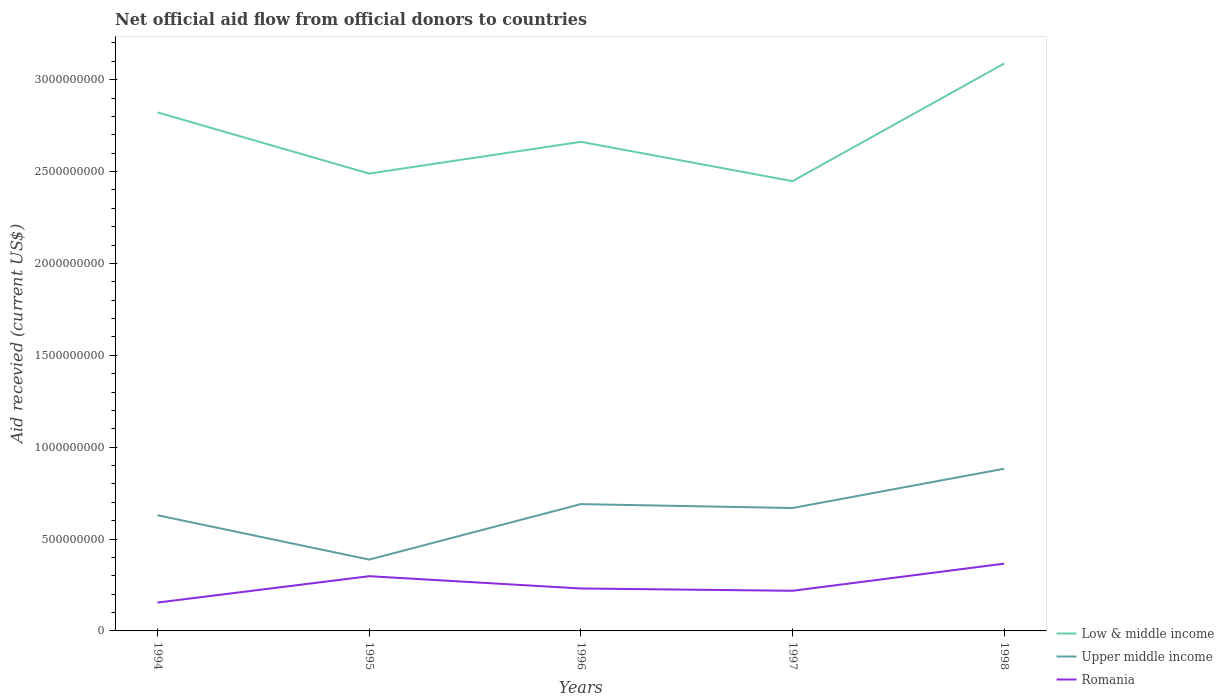Is the number of lines equal to the number of legend labels?
Give a very brief answer. Yes. Across all years, what is the maximum total aid received in Upper middle income?
Ensure brevity in your answer.  3.88e+08. In which year was the total aid received in Upper middle income maximum?
Offer a terse response. 1995. What is the total total aid received in Low & middle income in the graph?
Give a very brief answer. 2.14e+08. What is the difference between the highest and the second highest total aid received in Upper middle income?
Your response must be concise. 4.94e+08. What is the difference between the highest and the lowest total aid received in Upper middle income?
Provide a succinct answer. 3. How many years are there in the graph?
Offer a very short reply. 5. Are the values on the major ticks of Y-axis written in scientific E-notation?
Offer a very short reply. No. Does the graph contain grids?
Offer a very short reply. No. Where does the legend appear in the graph?
Ensure brevity in your answer.  Bottom right. How many legend labels are there?
Your response must be concise. 3. What is the title of the graph?
Provide a succinct answer. Net official aid flow from official donors to countries. What is the label or title of the X-axis?
Your answer should be compact. Years. What is the label or title of the Y-axis?
Ensure brevity in your answer.  Aid recevied (current US$). What is the Aid recevied (current US$) in Low & middle income in 1994?
Make the answer very short. 2.82e+09. What is the Aid recevied (current US$) in Upper middle income in 1994?
Give a very brief answer. 6.30e+08. What is the Aid recevied (current US$) of Romania in 1994?
Provide a short and direct response. 1.54e+08. What is the Aid recevied (current US$) of Low & middle income in 1995?
Provide a short and direct response. 2.49e+09. What is the Aid recevied (current US$) of Upper middle income in 1995?
Offer a very short reply. 3.88e+08. What is the Aid recevied (current US$) in Romania in 1995?
Provide a succinct answer. 2.98e+08. What is the Aid recevied (current US$) in Low & middle income in 1996?
Offer a terse response. 2.66e+09. What is the Aid recevied (current US$) of Upper middle income in 1996?
Offer a terse response. 6.90e+08. What is the Aid recevied (current US$) of Romania in 1996?
Your answer should be very brief. 2.31e+08. What is the Aid recevied (current US$) in Low & middle income in 1997?
Provide a succinct answer. 2.45e+09. What is the Aid recevied (current US$) of Upper middle income in 1997?
Your answer should be very brief. 6.69e+08. What is the Aid recevied (current US$) of Romania in 1997?
Provide a succinct answer. 2.18e+08. What is the Aid recevied (current US$) of Low & middle income in 1998?
Your response must be concise. 3.09e+09. What is the Aid recevied (current US$) of Upper middle income in 1998?
Offer a terse response. 8.83e+08. What is the Aid recevied (current US$) in Romania in 1998?
Offer a very short reply. 3.66e+08. Across all years, what is the maximum Aid recevied (current US$) in Low & middle income?
Offer a very short reply. 3.09e+09. Across all years, what is the maximum Aid recevied (current US$) in Upper middle income?
Offer a terse response. 8.83e+08. Across all years, what is the maximum Aid recevied (current US$) of Romania?
Give a very brief answer. 3.66e+08. Across all years, what is the minimum Aid recevied (current US$) in Low & middle income?
Offer a terse response. 2.45e+09. Across all years, what is the minimum Aid recevied (current US$) of Upper middle income?
Offer a terse response. 3.88e+08. Across all years, what is the minimum Aid recevied (current US$) in Romania?
Your answer should be very brief. 1.54e+08. What is the total Aid recevied (current US$) of Low & middle income in the graph?
Ensure brevity in your answer.  1.35e+1. What is the total Aid recevied (current US$) in Upper middle income in the graph?
Your answer should be very brief. 3.26e+09. What is the total Aid recevied (current US$) in Romania in the graph?
Your answer should be very brief. 1.27e+09. What is the difference between the Aid recevied (current US$) in Low & middle income in 1994 and that in 1995?
Make the answer very short. 3.33e+08. What is the difference between the Aid recevied (current US$) of Upper middle income in 1994 and that in 1995?
Provide a succinct answer. 2.41e+08. What is the difference between the Aid recevied (current US$) in Romania in 1994 and that in 1995?
Keep it short and to the point. -1.43e+08. What is the difference between the Aid recevied (current US$) in Low & middle income in 1994 and that in 1996?
Make the answer very short. 1.60e+08. What is the difference between the Aid recevied (current US$) of Upper middle income in 1994 and that in 1996?
Ensure brevity in your answer.  -6.04e+07. What is the difference between the Aid recevied (current US$) in Romania in 1994 and that in 1996?
Give a very brief answer. -7.65e+07. What is the difference between the Aid recevied (current US$) in Low & middle income in 1994 and that in 1997?
Offer a terse response. 3.74e+08. What is the difference between the Aid recevied (current US$) of Upper middle income in 1994 and that in 1997?
Offer a very short reply. -3.93e+07. What is the difference between the Aid recevied (current US$) of Romania in 1994 and that in 1997?
Keep it short and to the point. -6.40e+07. What is the difference between the Aid recevied (current US$) of Low & middle income in 1994 and that in 1998?
Your response must be concise. -2.66e+08. What is the difference between the Aid recevied (current US$) in Upper middle income in 1994 and that in 1998?
Your response must be concise. -2.53e+08. What is the difference between the Aid recevied (current US$) in Romania in 1994 and that in 1998?
Your answer should be very brief. -2.12e+08. What is the difference between the Aid recevied (current US$) of Low & middle income in 1995 and that in 1996?
Provide a succinct answer. -1.73e+08. What is the difference between the Aid recevied (current US$) in Upper middle income in 1995 and that in 1996?
Your answer should be very brief. -3.02e+08. What is the difference between the Aid recevied (current US$) in Romania in 1995 and that in 1996?
Make the answer very short. 6.69e+07. What is the difference between the Aid recevied (current US$) of Low & middle income in 1995 and that in 1997?
Your answer should be compact. 4.13e+07. What is the difference between the Aid recevied (current US$) in Upper middle income in 1995 and that in 1997?
Make the answer very short. -2.81e+08. What is the difference between the Aid recevied (current US$) of Romania in 1995 and that in 1997?
Your response must be concise. 7.94e+07. What is the difference between the Aid recevied (current US$) in Low & middle income in 1995 and that in 1998?
Keep it short and to the point. -5.99e+08. What is the difference between the Aid recevied (current US$) in Upper middle income in 1995 and that in 1998?
Make the answer very short. -4.94e+08. What is the difference between the Aid recevied (current US$) of Romania in 1995 and that in 1998?
Offer a terse response. -6.83e+07. What is the difference between the Aid recevied (current US$) of Low & middle income in 1996 and that in 1997?
Ensure brevity in your answer.  2.14e+08. What is the difference between the Aid recevied (current US$) of Upper middle income in 1996 and that in 1997?
Offer a very short reply. 2.11e+07. What is the difference between the Aid recevied (current US$) in Romania in 1996 and that in 1997?
Your answer should be very brief. 1.25e+07. What is the difference between the Aid recevied (current US$) in Low & middle income in 1996 and that in 1998?
Offer a terse response. -4.26e+08. What is the difference between the Aid recevied (current US$) of Upper middle income in 1996 and that in 1998?
Your answer should be compact. -1.93e+08. What is the difference between the Aid recevied (current US$) of Romania in 1996 and that in 1998?
Keep it short and to the point. -1.35e+08. What is the difference between the Aid recevied (current US$) in Low & middle income in 1997 and that in 1998?
Ensure brevity in your answer.  -6.40e+08. What is the difference between the Aid recevied (current US$) of Upper middle income in 1997 and that in 1998?
Offer a terse response. -2.14e+08. What is the difference between the Aid recevied (current US$) of Romania in 1997 and that in 1998?
Your answer should be very brief. -1.48e+08. What is the difference between the Aid recevied (current US$) in Low & middle income in 1994 and the Aid recevied (current US$) in Upper middle income in 1995?
Offer a terse response. 2.43e+09. What is the difference between the Aid recevied (current US$) in Low & middle income in 1994 and the Aid recevied (current US$) in Romania in 1995?
Give a very brief answer. 2.52e+09. What is the difference between the Aid recevied (current US$) in Upper middle income in 1994 and the Aid recevied (current US$) in Romania in 1995?
Give a very brief answer. 3.32e+08. What is the difference between the Aid recevied (current US$) in Low & middle income in 1994 and the Aid recevied (current US$) in Upper middle income in 1996?
Offer a very short reply. 2.13e+09. What is the difference between the Aid recevied (current US$) in Low & middle income in 1994 and the Aid recevied (current US$) in Romania in 1996?
Offer a terse response. 2.59e+09. What is the difference between the Aid recevied (current US$) in Upper middle income in 1994 and the Aid recevied (current US$) in Romania in 1996?
Make the answer very short. 3.99e+08. What is the difference between the Aid recevied (current US$) in Low & middle income in 1994 and the Aid recevied (current US$) in Upper middle income in 1997?
Give a very brief answer. 2.15e+09. What is the difference between the Aid recevied (current US$) of Low & middle income in 1994 and the Aid recevied (current US$) of Romania in 1997?
Your answer should be very brief. 2.60e+09. What is the difference between the Aid recevied (current US$) in Upper middle income in 1994 and the Aid recevied (current US$) in Romania in 1997?
Provide a short and direct response. 4.11e+08. What is the difference between the Aid recevied (current US$) in Low & middle income in 1994 and the Aid recevied (current US$) in Upper middle income in 1998?
Ensure brevity in your answer.  1.94e+09. What is the difference between the Aid recevied (current US$) in Low & middle income in 1994 and the Aid recevied (current US$) in Romania in 1998?
Your answer should be very brief. 2.46e+09. What is the difference between the Aid recevied (current US$) in Upper middle income in 1994 and the Aid recevied (current US$) in Romania in 1998?
Provide a succinct answer. 2.64e+08. What is the difference between the Aid recevied (current US$) in Low & middle income in 1995 and the Aid recevied (current US$) in Upper middle income in 1996?
Ensure brevity in your answer.  1.80e+09. What is the difference between the Aid recevied (current US$) of Low & middle income in 1995 and the Aid recevied (current US$) of Romania in 1996?
Offer a very short reply. 2.26e+09. What is the difference between the Aid recevied (current US$) of Upper middle income in 1995 and the Aid recevied (current US$) of Romania in 1996?
Make the answer very short. 1.57e+08. What is the difference between the Aid recevied (current US$) in Low & middle income in 1995 and the Aid recevied (current US$) in Upper middle income in 1997?
Offer a terse response. 1.82e+09. What is the difference between the Aid recevied (current US$) in Low & middle income in 1995 and the Aid recevied (current US$) in Romania in 1997?
Your response must be concise. 2.27e+09. What is the difference between the Aid recevied (current US$) of Upper middle income in 1995 and the Aid recevied (current US$) of Romania in 1997?
Keep it short and to the point. 1.70e+08. What is the difference between the Aid recevied (current US$) in Low & middle income in 1995 and the Aid recevied (current US$) in Upper middle income in 1998?
Make the answer very short. 1.61e+09. What is the difference between the Aid recevied (current US$) of Low & middle income in 1995 and the Aid recevied (current US$) of Romania in 1998?
Make the answer very short. 2.12e+09. What is the difference between the Aid recevied (current US$) of Upper middle income in 1995 and the Aid recevied (current US$) of Romania in 1998?
Provide a short and direct response. 2.21e+07. What is the difference between the Aid recevied (current US$) in Low & middle income in 1996 and the Aid recevied (current US$) in Upper middle income in 1997?
Offer a very short reply. 1.99e+09. What is the difference between the Aid recevied (current US$) in Low & middle income in 1996 and the Aid recevied (current US$) in Romania in 1997?
Keep it short and to the point. 2.44e+09. What is the difference between the Aid recevied (current US$) in Upper middle income in 1996 and the Aid recevied (current US$) in Romania in 1997?
Give a very brief answer. 4.72e+08. What is the difference between the Aid recevied (current US$) in Low & middle income in 1996 and the Aid recevied (current US$) in Upper middle income in 1998?
Offer a terse response. 1.78e+09. What is the difference between the Aid recevied (current US$) of Low & middle income in 1996 and the Aid recevied (current US$) of Romania in 1998?
Provide a succinct answer. 2.30e+09. What is the difference between the Aid recevied (current US$) in Upper middle income in 1996 and the Aid recevied (current US$) in Romania in 1998?
Make the answer very short. 3.24e+08. What is the difference between the Aid recevied (current US$) of Low & middle income in 1997 and the Aid recevied (current US$) of Upper middle income in 1998?
Make the answer very short. 1.57e+09. What is the difference between the Aid recevied (current US$) in Low & middle income in 1997 and the Aid recevied (current US$) in Romania in 1998?
Provide a short and direct response. 2.08e+09. What is the difference between the Aid recevied (current US$) of Upper middle income in 1997 and the Aid recevied (current US$) of Romania in 1998?
Your answer should be very brief. 3.03e+08. What is the average Aid recevied (current US$) of Low & middle income per year?
Provide a short and direct response. 2.70e+09. What is the average Aid recevied (current US$) in Upper middle income per year?
Give a very brief answer. 6.52e+08. What is the average Aid recevied (current US$) of Romania per year?
Give a very brief answer. 2.54e+08. In the year 1994, what is the difference between the Aid recevied (current US$) of Low & middle income and Aid recevied (current US$) of Upper middle income?
Your answer should be very brief. 2.19e+09. In the year 1994, what is the difference between the Aid recevied (current US$) of Low & middle income and Aid recevied (current US$) of Romania?
Your response must be concise. 2.67e+09. In the year 1994, what is the difference between the Aid recevied (current US$) in Upper middle income and Aid recevied (current US$) in Romania?
Offer a very short reply. 4.75e+08. In the year 1995, what is the difference between the Aid recevied (current US$) in Low & middle income and Aid recevied (current US$) in Upper middle income?
Give a very brief answer. 2.10e+09. In the year 1995, what is the difference between the Aid recevied (current US$) in Low & middle income and Aid recevied (current US$) in Romania?
Ensure brevity in your answer.  2.19e+09. In the year 1995, what is the difference between the Aid recevied (current US$) of Upper middle income and Aid recevied (current US$) of Romania?
Offer a terse response. 9.04e+07. In the year 1996, what is the difference between the Aid recevied (current US$) in Low & middle income and Aid recevied (current US$) in Upper middle income?
Give a very brief answer. 1.97e+09. In the year 1996, what is the difference between the Aid recevied (current US$) of Low & middle income and Aid recevied (current US$) of Romania?
Your response must be concise. 2.43e+09. In the year 1996, what is the difference between the Aid recevied (current US$) in Upper middle income and Aid recevied (current US$) in Romania?
Provide a succinct answer. 4.59e+08. In the year 1997, what is the difference between the Aid recevied (current US$) of Low & middle income and Aid recevied (current US$) of Upper middle income?
Provide a short and direct response. 1.78e+09. In the year 1997, what is the difference between the Aid recevied (current US$) of Low & middle income and Aid recevied (current US$) of Romania?
Ensure brevity in your answer.  2.23e+09. In the year 1997, what is the difference between the Aid recevied (current US$) in Upper middle income and Aid recevied (current US$) in Romania?
Provide a short and direct response. 4.51e+08. In the year 1998, what is the difference between the Aid recevied (current US$) of Low & middle income and Aid recevied (current US$) of Upper middle income?
Give a very brief answer. 2.21e+09. In the year 1998, what is the difference between the Aid recevied (current US$) of Low & middle income and Aid recevied (current US$) of Romania?
Provide a short and direct response. 2.72e+09. In the year 1998, what is the difference between the Aid recevied (current US$) in Upper middle income and Aid recevied (current US$) in Romania?
Your answer should be very brief. 5.17e+08. What is the ratio of the Aid recevied (current US$) in Low & middle income in 1994 to that in 1995?
Offer a very short reply. 1.13. What is the ratio of the Aid recevied (current US$) of Upper middle income in 1994 to that in 1995?
Ensure brevity in your answer.  1.62. What is the ratio of the Aid recevied (current US$) of Romania in 1994 to that in 1995?
Your response must be concise. 0.52. What is the ratio of the Aid recevied (current US$) of Low & middle income in 1994 to that in 1996?
Give a very brief answer. 1.06. What is the ratio of the Aid recevied (current US$) in Upper middle income in 1994 to that in 1996?
Ensure brevity in your answer.  0.91. What is the ratio of the Aid recevied (current US$) of Romania in 1994 to that in 1996?
Give a very brief answer. 0.67. What is the ratio of the Aid recevied (current US$) in Low & middle income in 1994 to that in 1997?
Offer a terse response. 1.15. What is the ratio of the Aid recevied (current US$) of Upper middle income in 1994 to that in 1997?
Make the answer very short. 0.94. What is the ratio of the Aid recevied (current US$) in Romania in 1994 to that in 1997?
Your response must be concise. 0.71. What is the ratio of the Aid recevied (current US$) in Low & middle income in 1994 to that in 1998?
Give a very brief answer. 0.91. What is the ratio of the Aid recevied (current US$) of Upper middle income in 1994 to that in 1998?
Ensure brevity in your answer.  0.71. What is the ratio of the Aid recevied (current US$) of Romania in 1994 to that in 1998?
Provide a succinct answer. 0.42. What is the ratio of the Aid recevied (current US$) in Low & middle income in 1995 to that in 1996?
Make the answer very short. 0.94. What is the ratio of the Aid recevied (current US$) of Upper middle income in 1995 to that in 1996?
Your answer should be very brief. 0.56. What is the ratio of the Aid recevied (current US$) of Romania in 1995 to that in 1996?
Offer a very short reply. 1.29. What is the ratio of the Aid recevied (current US$) of Low & middle income in 1995 to that in 1997?
Ensure brevity in your answer.  1.02. What is the ratio of the Aid recevied (current US$) in Upper middle income in 1995 to that in 1997?
Offer a very short reply. 0.58. What is the ratio of the Aid recevied (current US$) of Romania in 1995 to that in 1997?
Keep it short and to the point. 1.36. What is the ratio of the Aid recevied (current US$) in Low & middle income in 1995 to that in 1998?
Make the answer very short. 0.81. What is the ratio of the Aid recevied (current US$) of Upper middle income in 1995 to that in 1998?
Provide a short and direct response. 0.44. What is the ratio of the Aid recevied (current US$) of Romania in 1995 to that in 1998?
Provide a succinct answer. 0.81. What is the ratio of the Aid recevied (current US$) of Low & middle income in 1996 to that in 1997?
Provide a succinct answer. 1.09. What is the ratio of the Aid recevied (current US$) in Upper middle income in 1996 to that in 1997?
Ensure brevity in your answer.  1.03. What is the ratio of the Aid recevied (current US$) of Romania in 1996 to that in 1997?
Offer a terse response. 1.06. What is the ratio of the Aid recevied (current US$) of Low & middle income in 1996 to that in 1998?
Ensure brevity in your answer.  0.86. What is the ratio of the Aid recevied (current US$) of Upper middle income in 1996 to that in 1998?
Your answer should be very brief. 0.78. What is the ratio of the Aid recevied (current US$) in Romania in 1996 to that in 1998?
Ensure brevity in your answer.  0.63. What is the ratio of the Aid recevied (current US$) in Low & middle income in 1997 to that in 1998?
Make the answer very short. 0.79. What is the ratio of the Aid recevied (current US$) in Upper middle income in 1997 to that in 1998?
Provide a succinct answer. 0.76. What is the ratio of the Aid recevied (current US$) in Romania in 1997 to that in 1998?
Provide a succinct answer. 0.6. What is the difference between the highest and the second highest Aid recevied (current US$) of Low & middle income?
Offer a terse response. 2.66e+08. What is the difference between the highest and the second highest Aid recevied (current US$) of Upper middle income?
Give a very brief answer. 1.93e+08. What is the difference between the highest and the second highest Aid recevied (current US$) in Romania?
Provide a succinct answer. 6.83e+07. What is the difference between the highest and the lowest Aid recevied (current US$) of Low & middle income?
Make the answer very short. 6.40e+08. What is the difference between the highest and the lowest Aid recevied (current US$) in Upper middle income?
Make the answer very short. 4.94e+08. What is the difference between the highest and the lowest Aid recevied (current US$) in Romania?
Make the answer very short. 2.12e+08. 